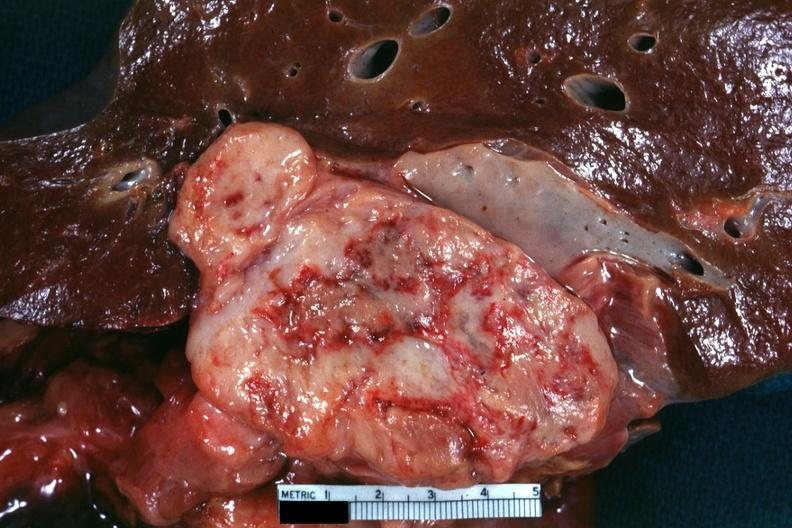s metastatic carcinoma present?
Answer the question using a single word or phrase. No 